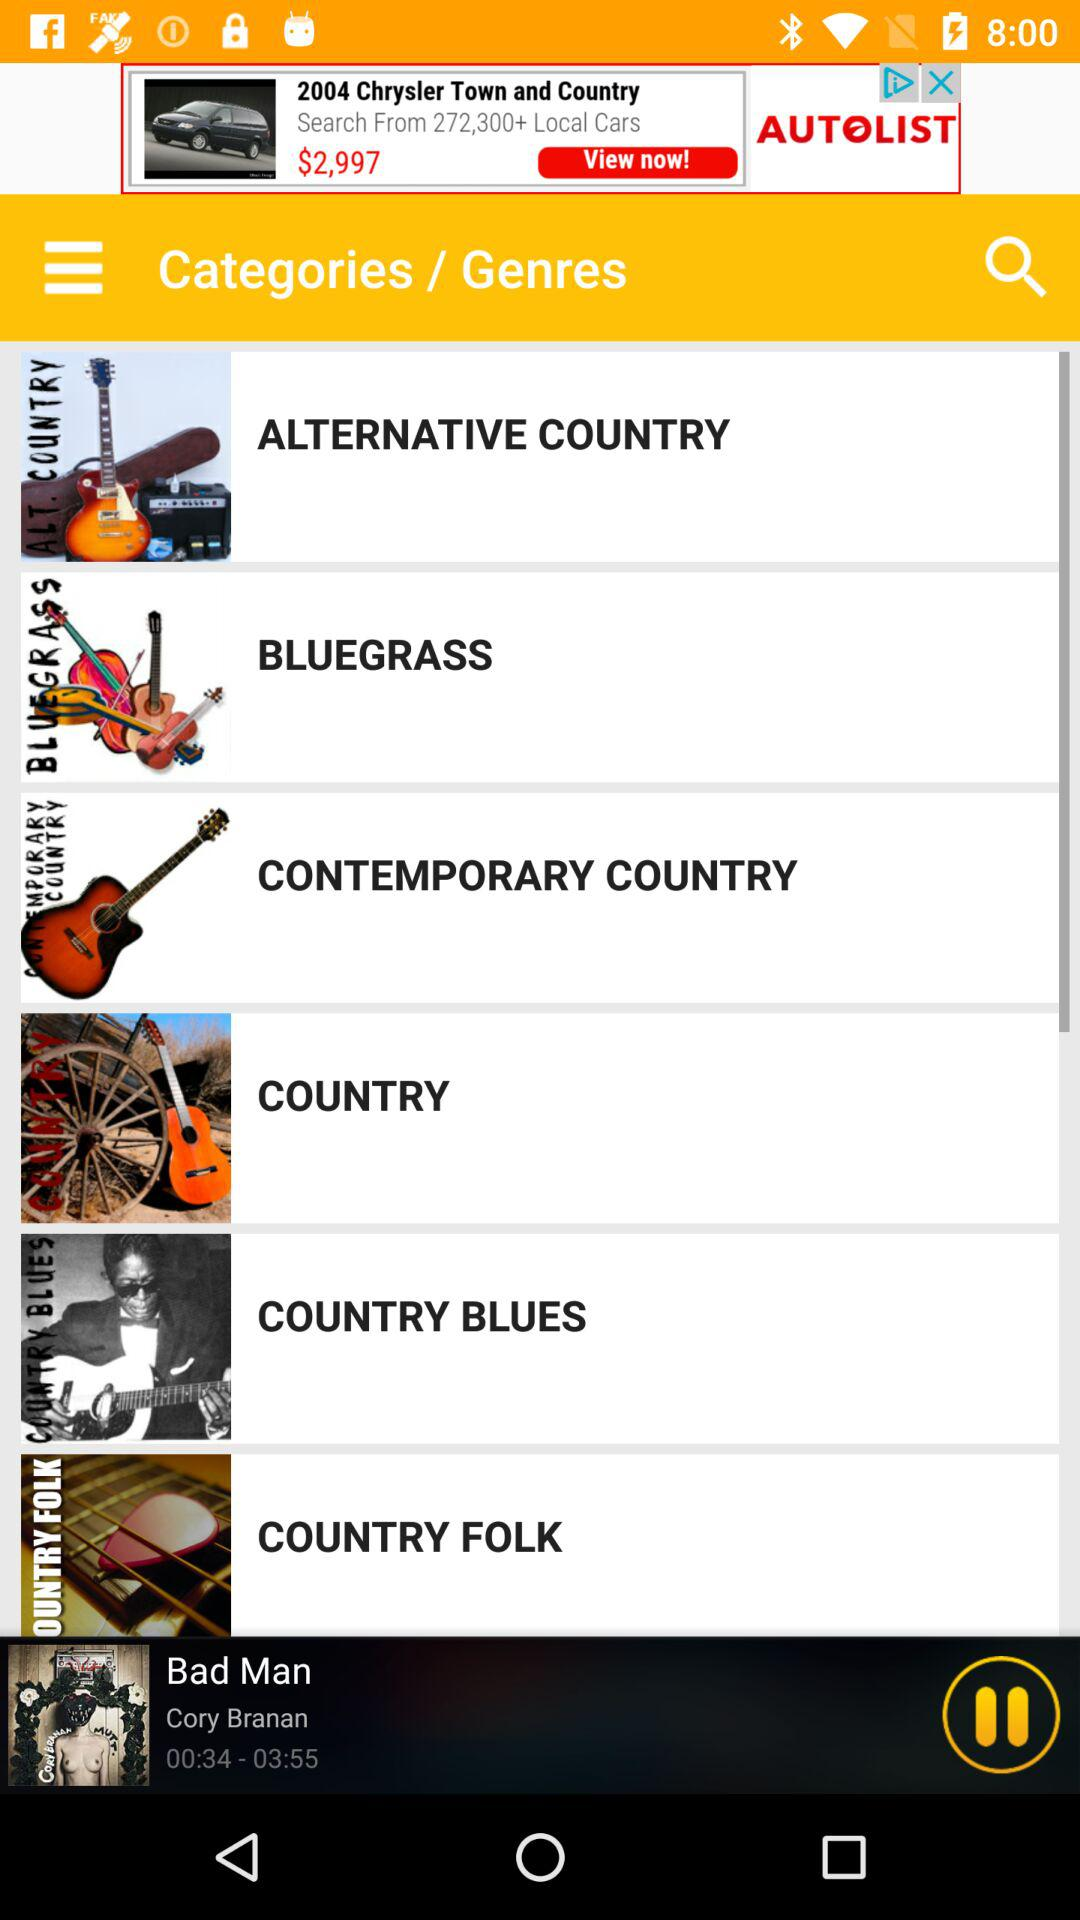Which song is currently playing? The currently playing song is "Bad Man". 